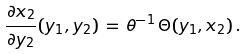<formula> <loc_0><loc_0><loc_500><loc_500>\frac { \partial x _ { 2 } } { \partial y _ { 2 } } ( y _ { 1 } , y _ { 2 } ) \, = \, \theta ^ { - 1 } \, \Theta ( y _ { 1 } , x _ { 2 } ) \, .</formula> 